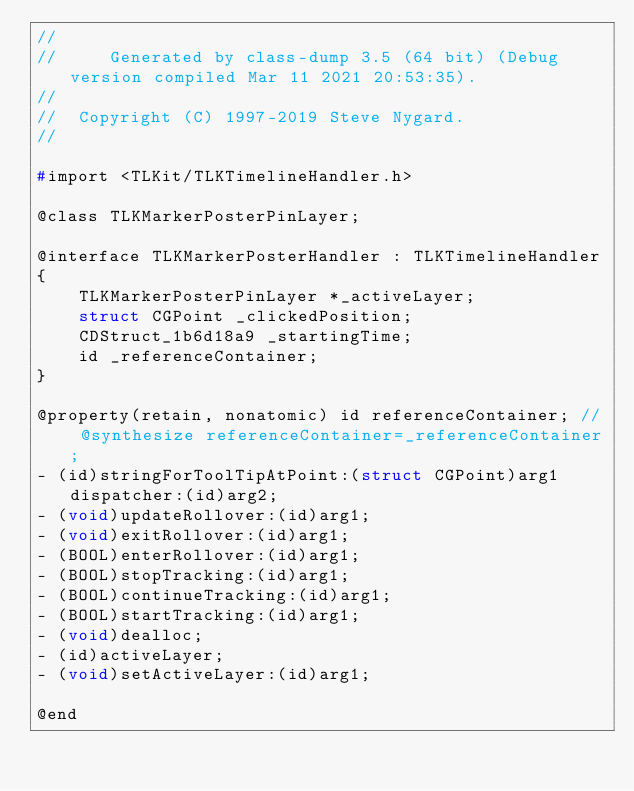Convert code to text. <code><loc_0><loc_0><loc_500><loc_500><_C_>//
//     Generated by class-dump 3.5 (64 bit) (Debug version compiled Mar 11 2021 20:53:35).
//
//  Copyright (C) 1997-2019 Steve Nygard.
//

#import <TLKit/TLKTimelineHandler.h>

@class TLKMarkerPosterPinLayer;

@interface TLKMarkerPosterHandler : TLKTimelineHandler
{
    TLKMarkerPosterPinLayer *_activeLayer;
    struct CGPoint _clickedPosition;
    CDStruct_1b6d18a9 _startingTime;
    id _referenceContainer;
}

@property(retain, nonatomic) id referenceContainer; // @synthesize referenceContainer=_referenceContainer;
- (id)stringForToolTipAtPoint:(struct CGPoint)arg1 dispatcher:(id)arg2;
- (void)updateRollover:(id)arg1;
- (void)exitRollover:(id)arg1;
- (BOOL)enterRollover:(id)arg1;
- (BOOL)stopTracking:(id)arg1;
- (BOOL)continueTracking:(id)arg1;
- (BOOL)startTracking:(id)arg1;
- (void)dealloc;
- (id)activeLayer;
- (void)setActiveLayer:(id)arg1;

@end

</code> 